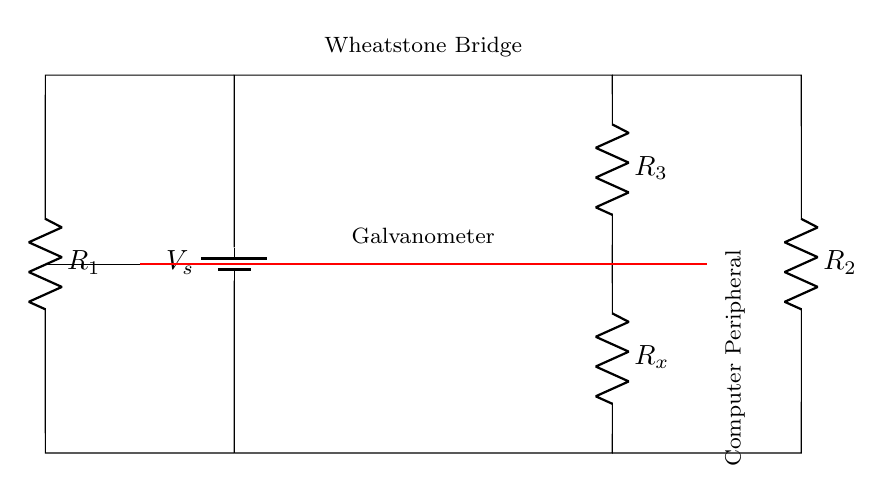What is the role of the galvanometer in this circuit? The galvanometer measures the current that flows between the two branches of the Wheatstone bridge. If the bridge is balanced, the current will be zero, indicating that the resistance values have been adjusted to match.
Answer: measures current What is the purpose of the resistors R1, R2, and R3 in the circuit? R1, R2, and R3 are known resistors that establish a ratio of resistances. They help in determining the unknown resistance Rx by balancing the bridge and ensuring that the circuit maintains specific voltage levels across the galvanometer.
Answer: establish ratios What is the variable component in this Wheatstone bridge circuit? The variable component is Rx, or the unknown resistance, which is to be measured against the known resistors R1, R2, and R3 in the circuit.
Answer: Rx How many resistors are present in the circuit? There are four resistors in total: R1, R2, R3, and the unknown resistor Rx.
Answer: four If the Wheatstone bridge is balanced, what can be deduced about the resistances? When the bridge is balanced, the ratio of R1 to R2 equals the ratio of R3 to Rx. This indicates that the unknown resistance can be calculated using the known resistors.
Answer: ratio equality What is the direction of current flow with respect to the galvanometer when the circuit is balanced? When balanced, the current flow through the galvanometer is zero, indicating no potential difference across it.
Answer: zero current 